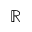<formula> <loc_0><loc_0><loc_500><loc_500>\mathbb { R }</formula> 